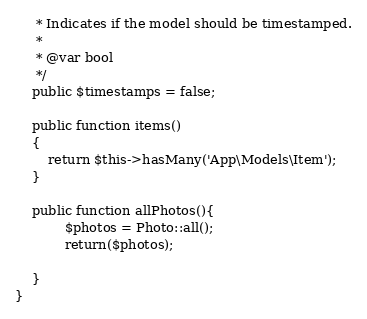Convert code to text. <code><loc_0><loc_0><loc_500><loc_500><_PHP_>     * Indicates if the model should be timestamped.
     *
     * @var bool
     */
    public $timestamps = false;

    public function items()
    {
        return $this->hasMany('App\Models\Item');
    }

    public function allPhotos(){
            $photos = Photo::all();
            return($photos);

    }
}</code> 